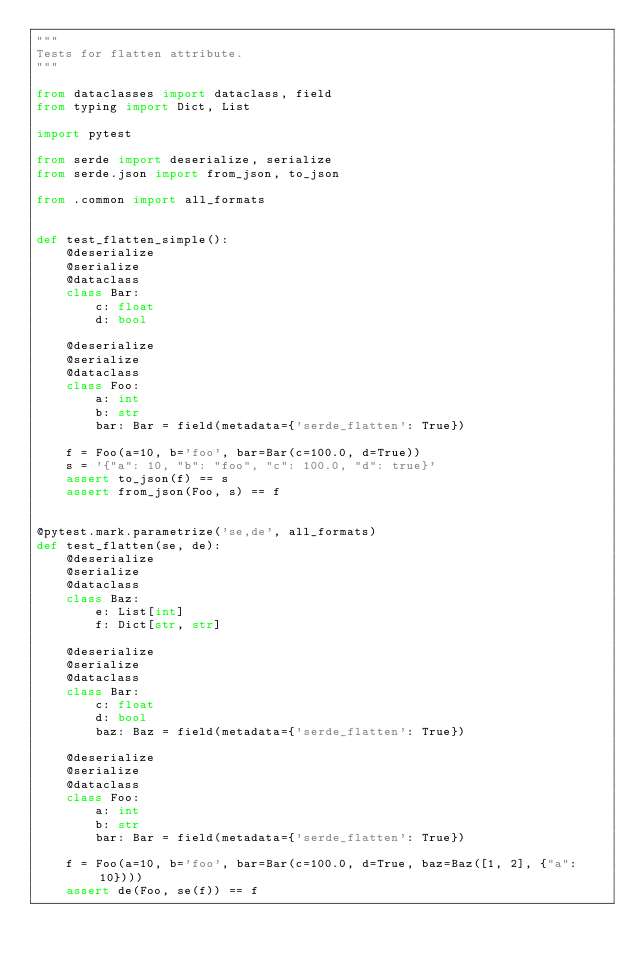Convert code to text. <code><loc_0><loc_0><loc_500><loc_500><_Python_>"""
Tests for flatten attribute.
"""

from dataclasses import dataclass, field
from typing import Dict, List

import pytest

from serde import deserialize, serialize
from serde.json import from_json, to_json

from .common import all_formats


def test_flatten_simple():
    @deserialize
    @serialize
    @dataclass
    class Bar:
        c: float
        d: bool

    @deserialize
    @serialize
    @dataclass
    class Foo:
        a: int
        b: str
        bar: Bar = field(metadata={'serde_flatten': True})

    f = Foo(a=10, b='foo', bar=Bar(c=100.0, d=True))
    s = '{"a": 10, "b": "foo", "c": 100.0, "d": true}'
    assert to_json(f) == s
    assert from_json(Foo, s) == f


@pytest.mark.parametrize('se,de', all_formats)
def test_flatten(se, de):
    @deserialize
    @serialize
    @dataclass
    class Baz:
        e: List[int]
        f: Dict[str, str]

    @deserialize
    @serialize
    @dataclass
    class Bar:
        c: float
        d: bool
        baz: Baz = field(metadata={'serde_flatten': True})

    @deserialize
    @serialize
    @dataclass
    class Foo:
        a: int
        b: str
        bar: Bar = field(metadata={'serde_flatten': True})

    f = Foo(a=10, b='foo', bar=Bar(c=100.0, d=True, baz=Baz([1, 2], {"a": 10})))
    assert de(Foo, se(f)) == f
</code> 